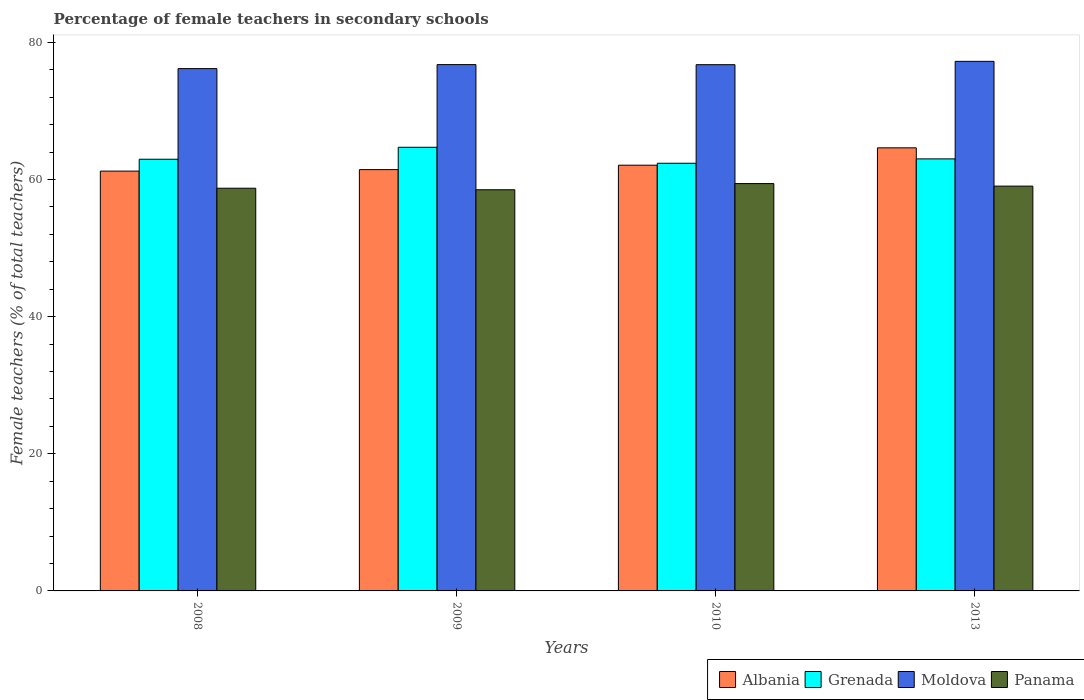How many different coloured bars are there?
Give a very brief answer. 4. How many groups of bars are there?
Provide a succinct answer. 4. Are the number of bars per tick equal to the number of legend labels?
Keep it short and to the point. Yes. How many bars are there on the 2nd tick from the right?
Offer a very short reply. 4. In how many cases, is the number of bars for a given year not equal to the number of legend labels?
Offer a terse response. 0. What is the percentage of female teachers in Grenada in 2013?
Ensure brevity in your answer.  63. Across all years, what is the maximum percentage of female teachers in Panama?
Provide a succinct answer. 59.4. Across all years, what is the minimum percentage of female teachers in Panama?
Provide a succinct answer. 58.5. In which year was the percentage of female teachers in Albania maximum?
Give a very brief answer. 2013. In which year was the percentage of female teachers in Grenada minimum?
Give a very brief answer. 2010. What is the total percentage of female teachers in Grenada in the graph?
Your answer should be compact. 253.02. What is the difference between the percentage of female teachers in Panama in 2010 and that in 2013?
Your answer should be very brief. 0.37. What is the difference between the percentage of female teachers in Panama in 2009 and the percentage of female teachers in Albania in 2013?
Provide a succinct answer. -6.11. What is the average percentage of female teachers in Panama per year?
Provide a succinct answer. 58.91. In the year 2010, what is the difference between the percentage of female teachers in Grenada and percentage of female teachers in Moldova?
Give a very brief answer. -14.38. What is the ratio of the percentage of female teachers in Grenada in 2008 to that in 2009?
Offer a terse response. 0.97. Is the percentage of female teachers in Grenada in 2008 less than that in 2010?
Your answer should be compact. No. What is the difference between the highest and the second highest percentage of female teachers in Grenada?
Make the answer very short. 1.69. What is the difference between the highest and the lowest percentage of female teachers in Grenada?
Provide a succinct answer. 2.33. What does the 4th bar from the left in 2013 represents?
Provide a succinct answer. Panama. What does the 1st bar from the right in 2009 represents?
Keep it short and to the point. Panama. Is it the case that in every year, the sum of the percentage of female teachers in Albania and percentage of female teachers in Panama is greater than the percentage of female teachers in Grenada?
Your answer should be very brief. Yes. What is the difference between two consecutive major ticks on the Y-axis?
Provide a short and direct response. 20. How are the legend labels stacked?
Ensure brevity in your answer.  Horizontal. What is the title of the graph?
Your answer should be compact. Percentage of female teachers in secondary schools. What is the label or title of the X-axis?
Make the answer very short. Years. What is the label or title of the Y-axis?
Make the answer very short. Female teachers (% of total teachers). What is the Female teachers (% of total teachers) in Albania in 2008?
Your answer should be very brief. 61.22. What is the Female teachers (% of total teachers) in Grenada in 2008?
Offer a very short reply. 62.95. What is the Female teachers (% of total teachers) of Moldova in 2008?
Your answer should be compact. 76.17. What is the Female teachers (% of total teachers) in Panama in 2008?
Ensure brevity in your answer.  58.72. What is the Female teachers (% of total teachers) in Albania in 2009?
Provide a succinct answer. 61.44. What is the Female teachers (% of total teachers) in Grenada in 2009?
Your response must be concise. 64.7. What is the Female teachers (% of total teachers) of Moldova in 2009?
Keep it short and to the point. 76.75. What is the Female teachers (% of total teachers) of Panama in 2009?
Provide a short and direct response. 58.5. What is the Female teachers (% of total teachers) in Albania in 2010?
Your answer should be compact. 62.08. What is the Female teachers (% of total teachers) in Grenada in 2010?
Your answer should be compact. 62.37. What is the Female teachers (% of total teachers) in Moldova in 2010?
Give a very brief answer. 76.74. What is the Female teachers (% of total teachers) of Panama in 2010?
Your answer should be compact. 59.4. What is the Female teachers (% of total teachers) in Albania in 2013?
Offer a terse response. 64.62. What is the Female teachers (% of total teachers) of Grenada in 2013?
Keep it short and to the point. 63. What is the Female teachers (% of total teachers) in Moldova in 2013?
Provide a succinct answer. 77.23. What is the Female teachers (% of total teachers) in Panama in 2013?
Make the answer very short. 59.03. Across all years, what is the maximum Female teachers (% of total teachers) of Albania?
Provide a succinct answer. 64.62. Across all years, what is the maximum Female teachers (% of total teachers) of Grenada?
Offer a terse response. 64.7. Across all years, what is the maximum Female teachers (% of total teachers) in Moldova?
Ensure brevity in your answer.  77.23. Across all years, what is the maximum Female teachers (% of total teachers) of Panama?
Provide a succinct answer. 59.4. Across all years, what is the minimum Female teachers (% of total teachers) of Albania?
Your response must be concise. 61.22. Across all years, what is the minimum Female teachers (% of total teachers) in Grenada?
Give a very brief answer. 62.37. Across all years, what is the minimum Female teachers (% of total teachers) in Moldova?
Your response must be concise. 76.17. Across all years, what is the minimum Female teachers (% of total teachers) in Panama?
Your response must be concise. 58.5. What is the total Female teachers (% of total teachers) of Albania in the graph?
Your answer should be very brief. 249.36. What is the total Female teachers (% of total teachers) in Grenada in the graph?
Your response must be concise. 253.02. What is the total Female teachers (% of total teachers) of Moldova in the graph?
Ensure brevity in your answer.  306.89. What is the total Female teachers (% of total teachers) of Panama in the graph?
Make the answer very short. 235.66. What is the difference between the Female teachers (% of total teachers) in Albania in 2008 and that in 2009?
Your answer should be compact. -0.22. What is the difference between the Female teachers (% of total teachers) in Grenada in 2008 and that in 2009?
Your response must be concise. -1.75. What is the difference between the Female teachers (% of total teachers) in Moldova in 2008 and that in 2009?
Make the answer very short. -0.58. What is the difference between the Female teachers (% of total teachers) in Panama in 2008 and that in 2009?
Ensure brevity in your answer.  0.22. What is the difference between the Female teachers (% of total teachers) of Albania in 2008 and that in 2010?
Make the answer very short. -0.86. What is the difference between the Female teachers (% of total teachers) in Grenada in 2008 and that in 2010?
Make the answer very short. 0.59. What is the difference between the Female teachers (% of total teachers) of Moldova in 2008 and that in 2010?
Keep it short and to the point. -0.57. What is the difference between the Female teachers (% of total teachers) in Panama in 2008 and that in 2010?
Offer a terse response. -0.68. What is the difference between the Female teachers (% of total teachers) of Albania in 2008 and that in 2013?
Provide a short and direct response. -3.4. What is the difference between the Female teachers (% of total teachers) of Grenada in 2008 and that in 2013?
Give a very brief answer. -0.05. What is the difference between the Female teachers (% of total teachers) of Moldova in 2008 and that in 2013?
Provide a short and direct response. -1.06. What is the difference between the Female teachers (% of total teachers) of Panama in 2008 and that in 2013?
Provide a succinct answer. -0.31. What is the difference between the Female teachers (% of total teachers) of Albania in 2009 and that in 2010?
Offer a very short reply. -0.64. What is the difference between the Female teachers (% of total teachers) of Grenada in 2009 and that in 2010?
Your answer should be compact. 2.33. What is the difference between the Female teachers (% of total teachers) in Moldova in 2009 and that in 2010?
Your response must be concise. 0.01. What is the difference between the Female teachers (% of total teachers) in Panama in 2009 and that in 2010?
Offer a very short reply. -0.9. What is the difference between the Female teachers (% of total teachers) in Albania in 2009 and that in 2013?
Provide a short and direct response. -3.18. What is the difference between the Female teachers (% of total teachers) in Grenada in 2009 and that in 2013?
Your answer should be compact. 1.69. What is the difference between the Female teachers (% of total teachers) in Moldova in 2009 and that in 2013?
Provide a succinct answer. -0.47. What is the difference between the Female teachers (% of total teachers) of Panama in 2009 and that in 2013?
Your answer should be very brief. -0.53. What is the difference between the Female teachers (% of total teachers) in Albania in 2010 and that in 2013?
Offer a terse response. -2.53. What is the difference between the Female teachers (% of total teachers) of Grenada in 2010 and that in 2013?
Provide a short and direct response. -0.64. What is the difference between the Female teachers (% of total teachers) of Moldova in 2010 and that in 2013?
Provide a short and direct response. -0.48. What is the difference between the Female teachers (% of total teachers) of Panama in 2010 and that in 2013?
Keep it short and to the point. 0.37. What is the difference between the Female teachers (% of total teachers) in Albania in 2008 and the Female teachers (% of total teachers) in Grenada in 2009?
Your answer should be compact. -3.48. What is the difference between the Female teachers (% of total teachers) of Albania in 2008 and the Female teachers (% of total teachers) of Moldova in 2009?
Ensure brevity in your answer.  -15.53. What is the difference between the Female teachers (% of total teachers) in Albania in 2008 and the Female teachers (% of total teachers) in Panama in 2009?
Your answer should be compact. 2.72. What is the difference between the Female teachers (% of total teachers) in Grenada in 2008 and the Female teachers (% of total teachers) in Moldova in 2009?
Provide a succinct answer. -13.8. What is the difference between the Female teachers (% of total teachers) of Grenada in 2008 and the Female teachers (% of total teachers) of Panama in 2009?
Provide a short and direct response. 4.45. What is the difference between the Female teachers (% of total teachers) in Moldova in 2008 and the Female teachers (% of total teachers) in Panama in 2009?
Ensure brevity in your answer.  17.67. What is the difference between the Female teachers (% of total teachers) in Albania in 2008 and the Female teachers (% of total teachers) in Grenada in 2010?
Ensure brevity in your answer.  -1.15. What is the difference between the Female teachers (% of total teachers) of Albania in 2008 and the Female teachers (% of total teachers) of Moldova in 2010?
Give a very brief answer. -15.52. What is the difference between the Female teachers (% of total teachers) in Albania in 2008 and the Female teachers (% of total teachers) in Panama in 2010?
Keep it short and to the point. 1.82. What is the difference between the Female teachers (% of total teachers) in Grenada in 2008 and the Female teachers (% of total teachers) in Moldova in 2010?
Provide a short and direct response. -13.79. What is the difference between the Female teachers (% of total teachers) in Grenada in 2008 and the Female teachers (% of total teachers) in Panama in 2010?
Offer a terse response. 3.55. What is the difference between the Female teachers (% of total teachers) of Moldova in 2008 and the Female teachers (% of total teachers) of Panama in 2010?
Offer a terse response. 16.77. What is the difference between the Female teachers (% of total teachers) of Albania in 2008 and the Female teachers (% of total teachers) of Grenada in 2013?
Offer a terse response. -1.78. What is the difference between the Female teachers (% of total teachers) of Albania in 2008 and the Female teachers (% of total teachers) of Moldova in 2013?
Offer a terse response. -16.01. What is the difference between the Female teachers (% of total teachers) of Albania in 2008 and the Female teachers (% of total teachers) of Panama in 2013?
Offer a very short reply. 2.19. What is the difference between the Female teachers (% of total teachers) in Grenada in 2008 and the Female teachers (% of total teachers) in Moldova in 2013?
Offer a terse response. -14.28. What is the difference between the Female teachers (% of total teachers) in Grenada in 2008 and the Female teachers (% of total teachers) in Panama in 2013?
Provide a succinct answer. 3.92. What is the difference between the Female teachers (% of total teachers) in Moldova in 2008 and the Female teachers (% of total teachers) in Panama in 2013?
Your answer should be very brief. 17.14. What is the difference between the Female teachers (% of total teachers) in Albania in 2009 and the Female teachers (% of total teachers) in Grenada in 2010?
Provide a succinct answer. -0.93. What is the difference between the Female teachers (% of total teachers) of Albania in 2009 and the Female teachers (% of total teachers) of Moldova in 2010?
Provide a succinct answer. -15.3. What is the difference between the Female teachers (% of total teachers) of Albania in 2009 and the Female teachers (% of total teachers) of Panama in 2010?
Provide a short and direct response. 2.04. What is the difference between the Female teachers (% of total teachers) of Grenada in 2009 and the Female teachers (% of total teachers) of Moldova in 2010?
Keep it short and to the point. -12.05. What is the difference between the Female teachers (% of total teachers) of Grenada in 2009 and the Female teachers (% of total teachers) of Panama in 2010?
Your answer should be compact. 5.3. What is the difference between the Female teachers (% of total teachers) of Moldova in 2009 and the Female teachers (% of total teachers) of Panama in 2010?
Provide a short and direct response. 17.35. What is the difference between the Female teachers (% of total teachers) of Albania in 2009 and the Female teachers (% of total teachers) of Grenada in 2013?
Your response must be concise. -1.56. What is the difference between the Female teachers (% of total teachers) of Albania in 2009 and the Female teachers (% of total teachers) of Moldova in 2013?
Offer a very short reply. -15.79. What is the difference between the Female teachers (% of total teachers) of Albania in 2009 and the Female teachers (% of total teachers) of Panama in 2013?
Your answer should be compact. 2.41. What is the difference between the Female teachers (% of total teachers) of Grenada in 2009 and the Female teachers (% of total teachers) of Moldova in 2013?
Your answer should be compact. -12.53. What is the difference between the Female teachers (% of total teachers) of Grenada in 2009 and the Female teachers (% of total teachers) of Panama in 2013?
Make the answer very short. 5.67. What is the difference between the Female teachers (% of total teachers) in Moldova in 2009 and the Female teachers (% of total teachers) in Panama in 2013?
Give a very brief answer. 17.72. What is the difference between the Female teachers (% of total teachers) in Albania in 2010 and the Female teachers (% of total teachers) in Grenada in 2013?
Provide a short and direct response. -0.92. What is the difference between the Female teachers (% of total teachers) of Albania in 2010 and the Female teachers (% of total teachers) of Moldova in 2013?
Your response must be concise. -15.14. What is the difference between the Female teachers (% of total teachers) in Albania in 2010 and the Female teachers (% of total teachers) in Panama in 2013?
Ensure brevity in your answer.  3.05. What is the difference between the Female teachers (% of total teachers) in Grenada in 2010 and the Female teachers (% of total teachers) in Moldova in 2013?
Offer a terse response. -14.86. What is the difference between the Female teachers (% of total teachers) in Grenada in 2010 and the Female teachers (% of total teachers) in Panama in 2013?
Offer a terse response. 3.33. What is the difference between the Female teachers (% of total teachers) of Moldova in 2010 and the Female teachers (% of total teachers) of Panama in 2013?
Ensure brevity in your answer.  17.71. What is the average Female teachers (% of total teachers) of Albania per year?
Offer a very short reply. 62.34. What is the average Female teachers (% of total teachers) of Grenada per year?
Offer a very short reply. 63.25. What is the average Female teachers (% of total teachers) in Moldova per year?
Offer a very short reply. 76.72. What is the average Female teachers (% of total teachers) in Panama per year?
Your response must be concise. 58.91. In the year 2008, what is the difference between the Female teachers (% of total teachers) of Albania and Female teachers (% of total teachers) of Grenada?
Provide a succinct answer. -1.73. In the year 2008, what is the difference between the Female teachers (% of total teachers) of Albania and Female teachers (% of total teachers) of Moldova?
Provide a short and direct response. -14.95. In the year 2008, what is the difference between the Female teachers (% of total teachers) of Albania and Female teachers (% of total teachers) of Panama?
Your answer should be very brief. 2.5. In the year 2008, what is the difference between the Female teachers (% of total teachers) of Grenada and Female teachers (% of total teachers) of Moldova?
Ensure brevity in your answer.  -13.22. In the year 2008, what is the difference between the Female teachers (% of total teachers) in Grenada and Female teachers (% of total teachers) in Panama?
Your answer should be compact. 4.23. In the year 2008, what is the difference between the Female teachers (% of total teachers) of Moldova and Female teachers (% of total teachers) of Panama?
Ensure brevity in your answer.  17.44. In the year 2009, what is the difference between the Female teachers (% of total teachers) of Albania and Female teachers (% of total teachers) of Grenada?
Provide a short and direct response. -3.26. In the year 2009, what is the difference between the Female teachers (% of total teachers) of Albania and Female teachers (% of total teachers) of Moldova?
Keep it short and to the point. -15.31. In the year 2009, what is the difference between the Female teachers (% of total teachers) of Albania and Female teachers (% of total teachers) of Panama?
Your response must be concise. 2.94. In the year 2009, what is the difference between the Female teachers (% of total teachers) of Grenada and Female teachers (% of total teachers) of Moldova?
Your response must be concise. -12.06. In the year 2009, what is the difference between the Female teachers (% of total teachers) in Grenada and Female teachers (% of total teachers) in Panama?
Offer a terse response. 6.2. In the year 2009, what is the difference between the Female teachers (% of total teachers) in Moldova and Female teachers (% of total teachers) in Panama?
Provide a succinct answer. 18.25. In the year 2010, what is the difference between the Female teachers (% of total teachers) of Albania and Female teachers (% of total teachers) of Grenada?
Provide a short and direct response. -0.28. In the year 2010, what is the difference between the Female teachers (% of total teachers) of Albania and Female teachers (% of total teachers) of Moldova?
Make the answer very short. -14.66. In the year 2010, what is the difference between the Female teachers (% of total teachers) in Albania and Female teachers (% of total teachers) in Panama?
Provide a short and direct response. 2.68. In the year 2010, what is the difference between the Female teachers (% of total teachers) in Grenada and Female teachers (% of total teachers) in Moldova?
Ensure brevity in your answer.  -14.38. In the year 2010, what is the difference between the Female teachers (% of total teachers) of Grenada and Female teachers (% of total teachers) of Panama?
Make the answer very short. 2.96. In the year 2010, what is the difference between the Female teachers (% of total teachers) of Moldova and Female teachers (% of total teachers) of Panama?
Keep it short and to the point. 17.34. In the year 2013, what is the difference between the Female teachers (% of total teachers) in Albania and Female teachers (% of total teachers) in Grenada?
Keep it short and to the point. 1.61. In the year 2013, what is the difference between the Female teachers (% of total teachers) in Albania and Female teachers (% of total teachers) in Moldova?
Your answer should be compact. -12.61. In the year 2013, what is the difference between the Female teachers (% of total teachers) of Albania and Female teachers (% of total teachers) of Panama?
Give a very brief answer. 5.58. In the year 2013, what is the difference between the Female teachers (% of total teachers) of Grenada and Female teachers (% of total teachers) of Moldova?
Keep it short and to the point. -14.22. In the year 2013, what is the difference between the Female teachers (% of total teachers) of Grenada and Female teachers (% of total teachers) of Panama?
Provide a succinct answer. 3.97. In the year 2013, what is the difference between the Female teachers (% of total teachers) in Moldova and Female teachers (% of total teachers) in Panama?
Offer a very short reply. 18.2. What is the ratio of the Female teachers (% of total teachers) in Albania in 2008 to that in 2009?
Offer a very short reply. 1. What is the ratio of the Female teachers (% of total teachers) in Moldova in 2008 to that in 2009?
Your response must be concise. 0.99. What is the ratio of the Female teachers (% of total teachers) in Panama in 2008 to that in 2009?
Keep it short and to the point. 1. What is the ratio of the Female teachers (% of total teachers) of Albania in 2008 to that in 2010?
Provide a short and direct response. 0.99. What is the ratio of the Female teachers (% of total teachers) of Grenada in 2008 to that in 2010?
Give a very brief answer. 1.01. What is the ratio of the Female teachers (% of total teachers) of Moldova in 2008 to that in 2010?
Provide a short and direct response. 0.99. What is the ratio of the Female teachers (% of total teachers) of Panama in 2008 to that in 2010?
Offer a very short reply. 0.99. What is the ratio of the Female teachers (% of total teachers) of Moldova in 2008 to that in 2013?
Offer a very short reply. 0.99. What is the ratio of the Female teachers (% of total teachers) in Panama in 2008 to that in 2013?
Provide a short and direct response. 0.99. What is the ratio of the Female teachers (% of total teachers) of Grenada in 2009 to that in 2010?
Make the answer very short. 1.04. What is the ratio of the Female teachers (% of total teachers) of Moldova in 2009 to that in 2010?
Give a very brief answer. 1. What is the ratio of the Female teachers (% of total teachers) in Albania in 2009 to that in 2013?
Give a very brief answer. 0.95. What is the ratio of the Female teachers (% of total teachers) in Grenada in 2009 to that in 2013?
Offer a terse response. 1.03. What is the ratio of the Female teachers (% of total teachers) of Panama in 2009 to that in 2013?
Make the answer very short. 0.99. What is the ratio of the Female teachers (% of total teachers) of Albania in 2010 to that in 2013?
Offer a terse response. 0.96. What is the ratio of the Female teachers (% of total teachers) of Moldova in 2010 to that in 2013?
Keep it short and to the point. 0.99. What is the ratio of the Female teachers (% of total teachers) of Panama in 2010 to that in 2013?
Make the answer very short. 1.01. What is the difference between the highest and the second highest Female teachers (% of total teachers) of Albania?
Your answer should be compact. 2.53. What is the difference between the highest and the second highest Female teachers (% of total teachers) of Grenada?
Give a very brief answer. 1.69. What is the difference between the highest and the second highest Female teachers (% of total teachers) of Moldova?
Your response must be concise. 0.47. What is the difference between the highest and the second highest Female teachers (% of total teachers) in Panama?
Provide a short and direct response. 0.37. What is the difference between the highest and the lowest Female teachers (% of total teachers) in Albania?
Ensure brevity in your answer.  3.4. What is the difference between the highest and the lowest Female teachers (% of total teachers) of Grenada?
Give a very brief answer. 2.33. What is the difference between the highest and the lowest Female teachers (% of total teachers) of Moldova?
Offer a very short reply. 1.06. What is the difference between the highest and the lowest Female teachers (% of total teachers) in Panama?
Offer a very short reply. 0.9. 